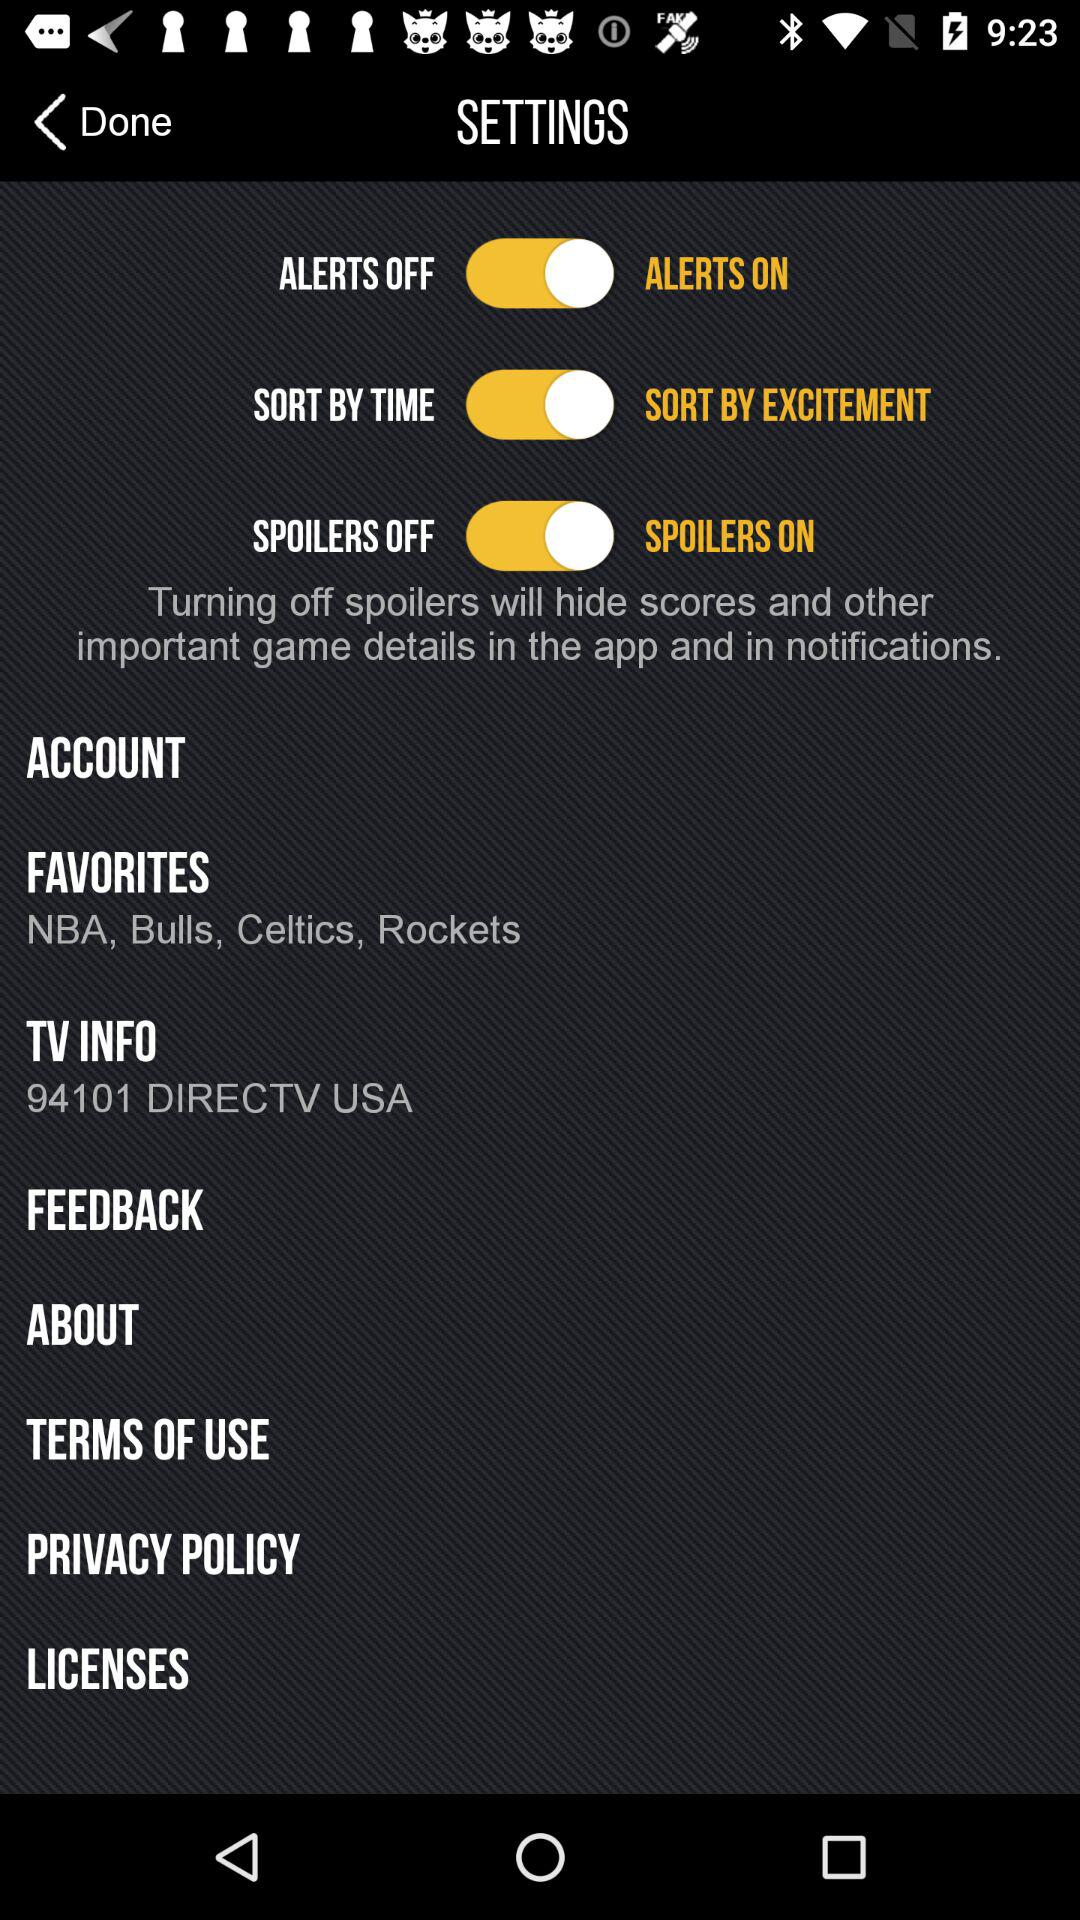What is the status of "SORT BY EXCITEMENT"? The status of "SORT BY EXCITEMENT" is "on". 